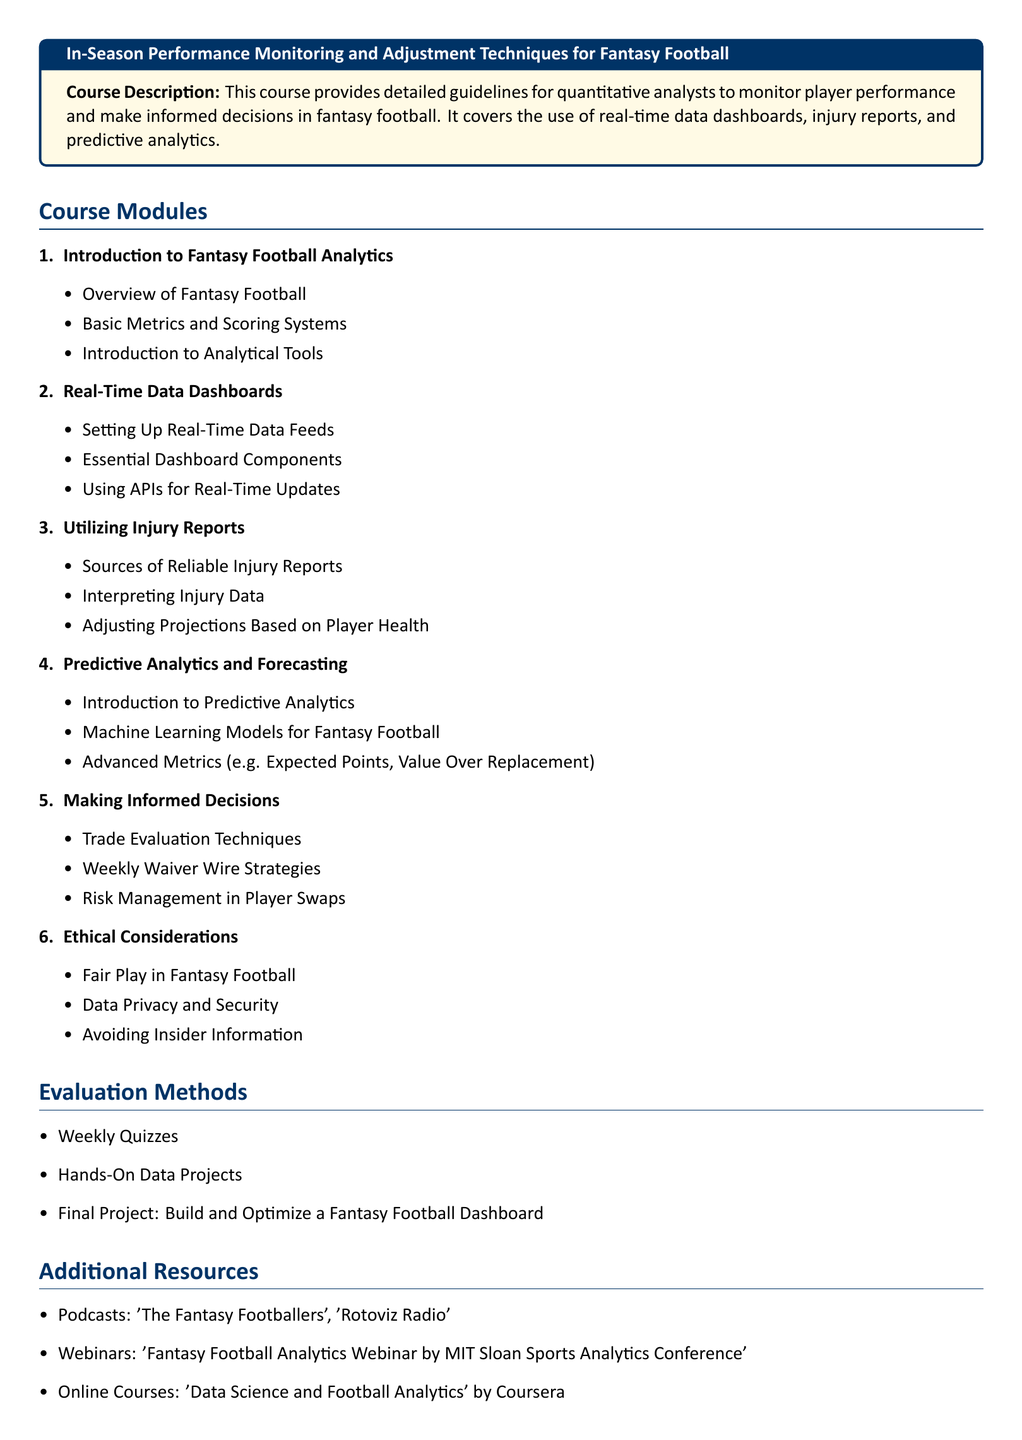What is the course title? The title is provided at the beginning of the document within a highlighted box.
Answer: In-Season Performance Monitoring and Adjustment Techniques for Fantasy Football How many course modules are outlined in the document? The number of modules can be found by counting the items in the Course Modules section.
Answer: 6 What is one of the additional resources listed? Additional resources are provided in a bulleted list towards the end of the document.
Answer: Podcasts: 'The Fantasy Footballers' What is a technique for evaluating trades mentioned in the syllabus? The course outlines specific strategies within the Making Informed Decisions module.
Answer: Trade Evaluation Techniques What type of evaluation method involves building a dashboard? The Evaluation Methods section lists various methods for assessment, including this specific project.
Answer: Final Project What is the focus of the third module? The module headings provide a summary of each focus area in the course structure.
Answer: Utilizing Injury Reports What is a key aspect mentioned in the Ethical Considerations section? This section outlines principles that uphold fairness and privacy in fantasy sports.
Answer: Fair Play in Fantasy Football What kind of models are introduced in the Predictive Analytics and Forecasting module? The content of each module reveals the analytical techniques being discussed.
Answer: Machine Learning Models How does the course structure categorize information? The structure is defined by grouping subjects into Modules and subsections for clarity.
Answer: Modules 